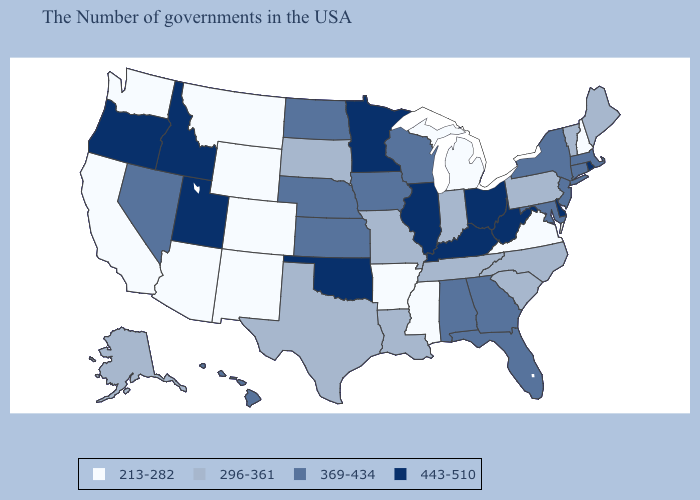Which states hav the highest value in the Northeast?
Answer briefly. Rhode Island. Which states have the lowest value in the West?
Short answer required. Wyoming, Colorado, New Mexico, Montana, Arizona, California, Washington. What is the lowest value in the South?
Be succinct. 213-282. What is the value of Indiana?
Write a very short answer. 296-361. Name the states that have a value in the range 213-282?
Concise answer only. New Hampshire, Virginia, Michigan, Mississippi, Arkansas, Wyoming, Colorado, New Mexico, Montana, Arizona, California, Washington. What is the value of West Virginia?
Write a very short answer. 443-510. Among the states that border Montana , which have the highest value?
Keep it brief. Idaho. Name the states that have a value in the range 213-282?
Be succinct. New Hampshire, Virginia, Michigan, Mississippi, Arkansas, Wyoming, Colorado, New Mexico, Montana, Arizona, California, Washington. What is the value of Ohio?
Give a very brief answer. 443-510. What is the value of North Carolina?
Give a very brief answer. 296-361. Does the map have missing data?
Be succinct. No. What is the value of Vermont?
Short answer required. 296-361. Does the first symbol in the legend represent the smallest category?
Be succinct. Yes. 